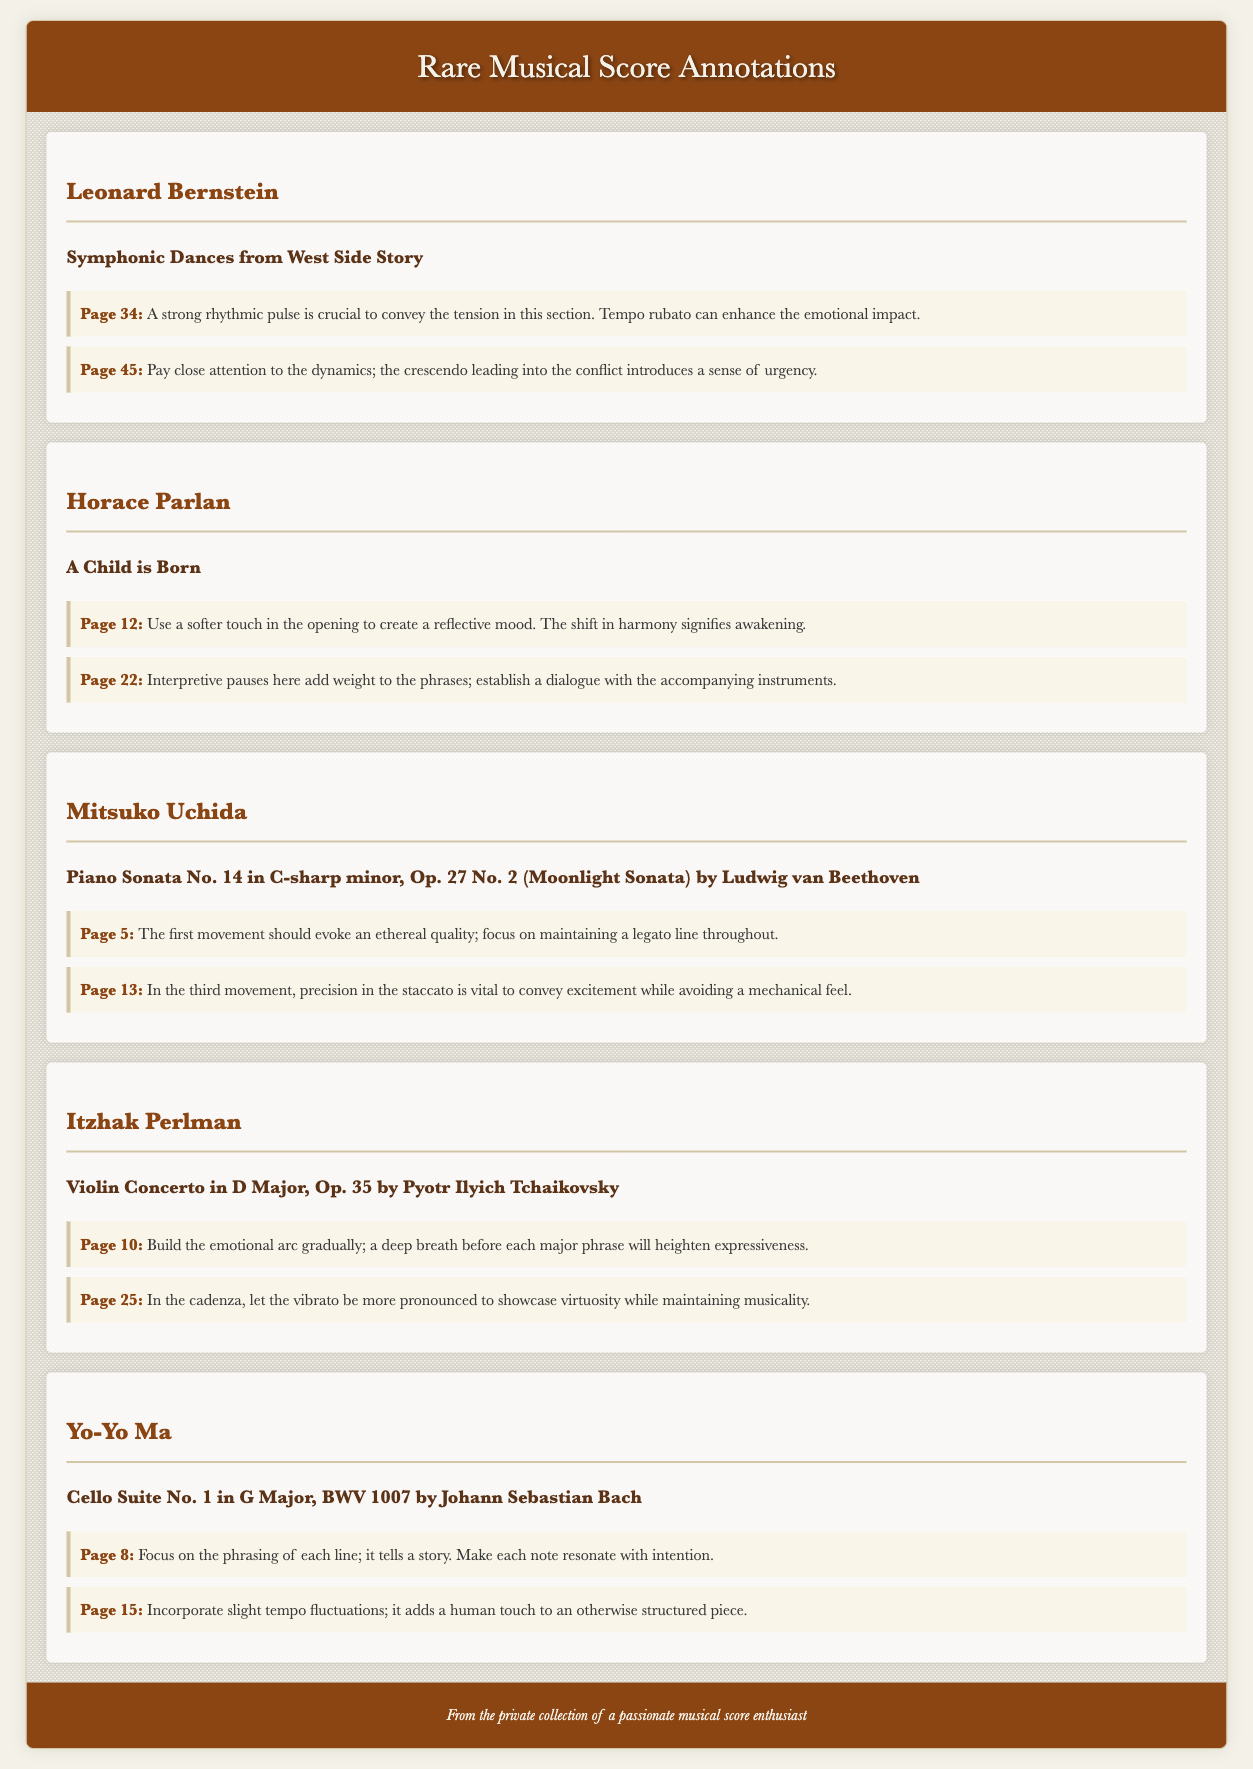What is the title of the work annotated by Leonard Bernstein? The title is "Symphonic Dances from West Side Story," as stated in the collection item for Bernstein.
Answer: Symphonic Dances from West Side Story What page number mentions the importance of tempo rubato? The page number is 34, where it discusses the use of tempo rubato to enhance emotional impact.
Answer: Page 34 Who provided annotations for "A Child is Born"? The annotations are attributed to Horace Parlan, as indicated in the collection item header.
Answer: Horace Parlan What is the recommendation for the first movement of Moonlight Sonata? The recommendation is to evoke an ethereal quality and maintain a legato line throughout, found in the annotation for page 5.
Answer: Ethereal quality; maintain a legato line How does Itzhak Perlman suggest building the emotional arc in the Violin Concerto? He suggests building it gradually, with a deep breath before each major phrase, as noted in page 10 annotations.
Answer: Gradually What is the significance of phrasing in Yo-Yo Ma's annotations on Cello Suite No. 1? The significance is that it tells a story and each note should resonate with intention, according to the annotation on page 8.
Answer: It tells a story What general interpretation advice is given by Mitsuko Uchida for the third movement of the Moonlight Sonata? The advice emphasizes precision in staccato to convey excitement while avoiding a mechanical feel, as stated on page 13.
Answer: Precision in staccato How many collection items are included in this document? There are five collection items listed in the document, covering different musicians and their annotations.
Answer: Five 